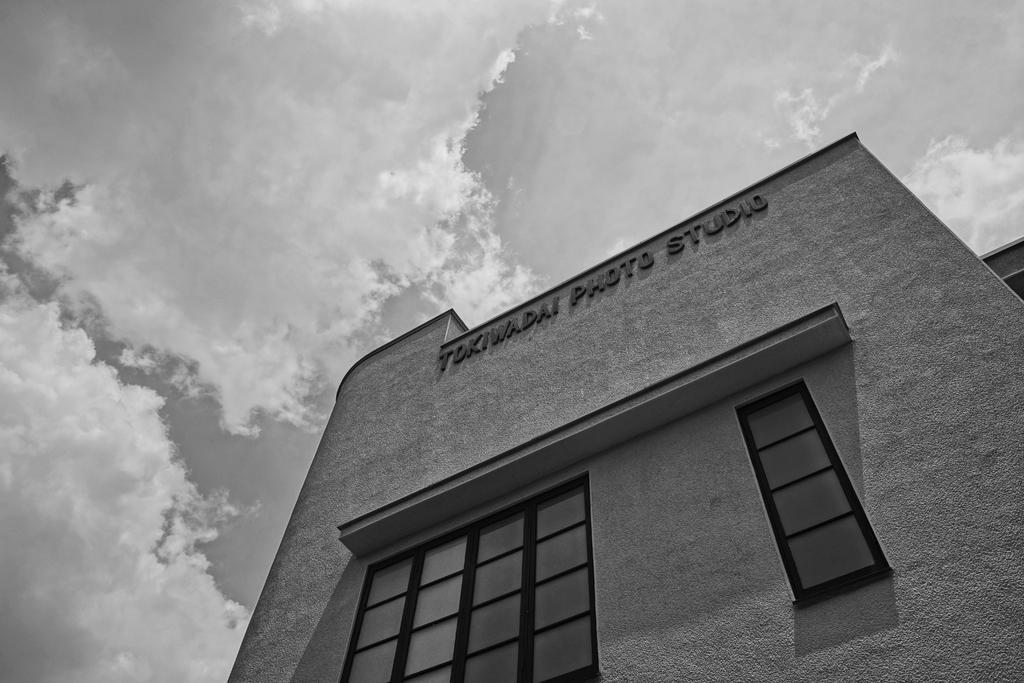Can you describe this image briefly? This is a black and white picture. In front of the picture, we see a building. It has the glass windows. On top of the building, it is written as "TOKIWADAI PHOTO STUDIO". In the background, we see the sky and the clouds. 